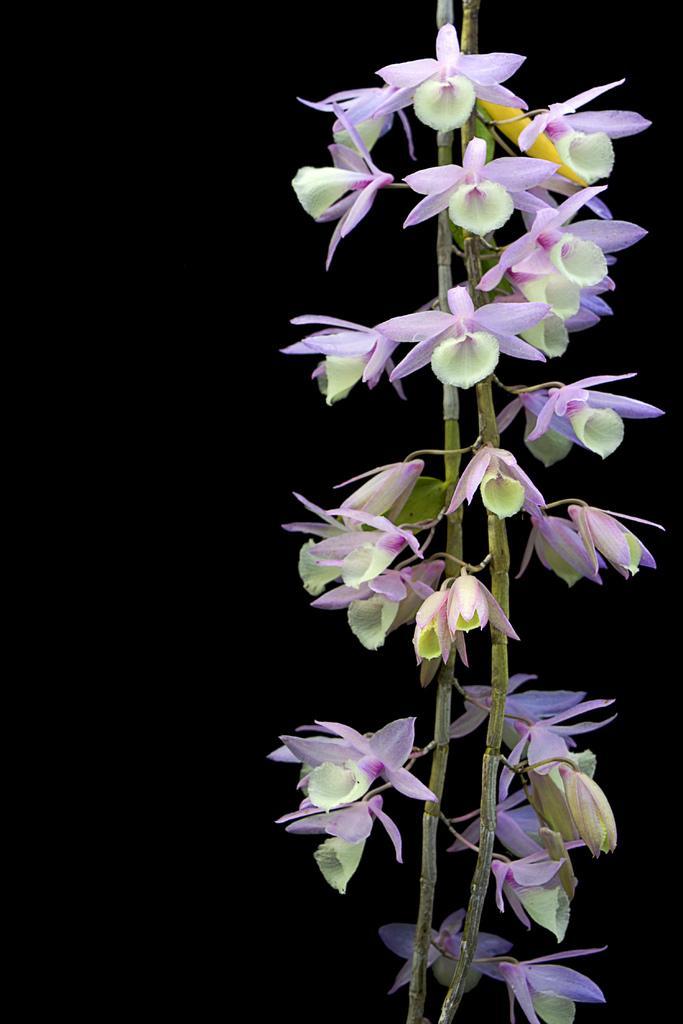Describe this image in one or two sentences. This image consists of a plant. To which we can see the flowers in purple color. The background is too dark. 